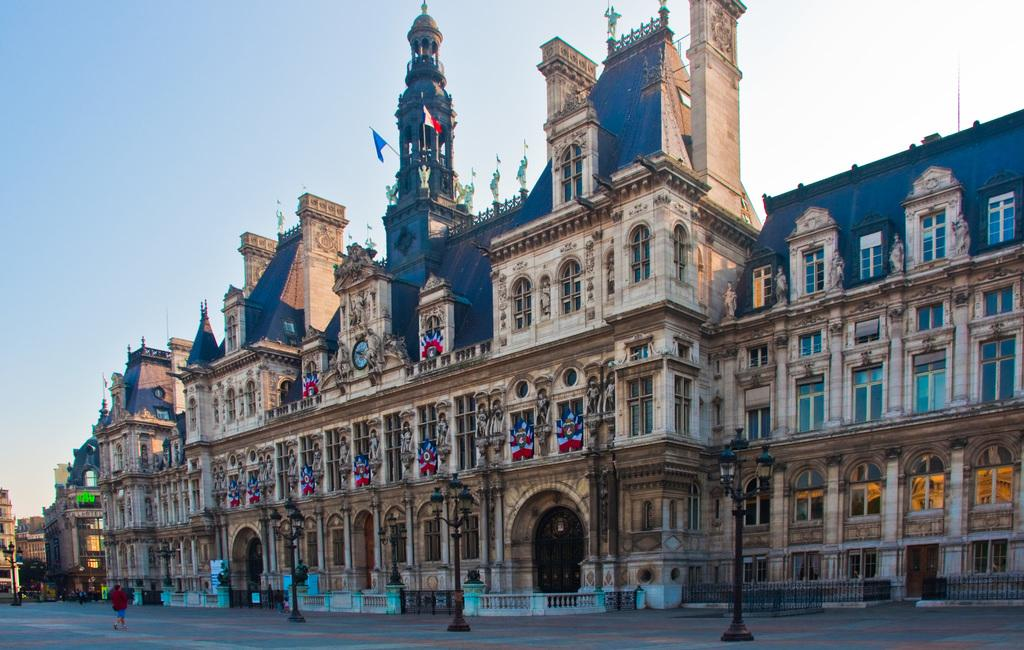What is located in the center of the image? There are buildings in the center of the image. What can be seen at the bottom of the image? There are poles at the bottom of the image. What is visible in the background of the image? The sky is visible in the background of the image. What is the person on the left side of the image doing? There is a person walking on the left side of the image. What type of wound can be seen on the person's hands in the image? There is no person with a wound on their hands in the image. How many eggs are visible in the image? There are no eggs present in the image. 